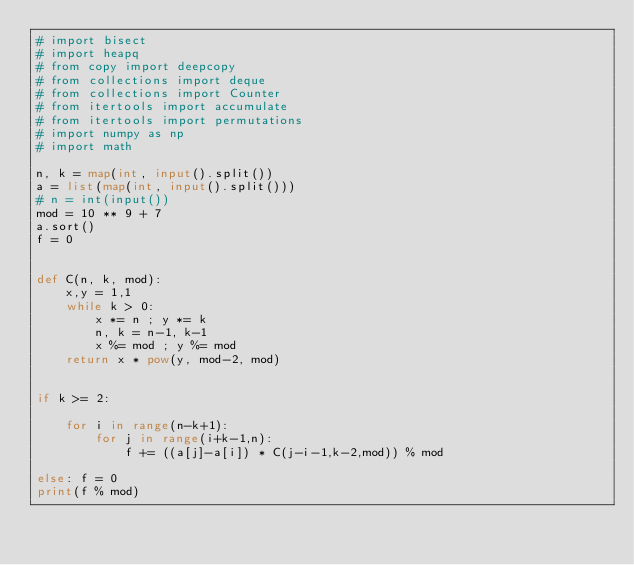<code> <loc_0><loc_0><loc_500><loc_500><_Python_># import bisect
# import heapq
# from copy import deepcopy
# from collections import deque
# from collections import Counter
# from itertools import accumulate
# from itertools import permutations
# import numpy as np
# import math

n, k = map(int, input().split())
a = list(map(int, input().split()))
# n = int(input())
mod = 10 ** 9 + 7
a.sort()
f = 0


def C(n, k, mod):
    x,y = 1,1
    while k > 0:
        x *= n ; y *= k
        n, k = n-1, k-1
        x %= mod ; y %= mod
    return x * pow(y, mod-2, mod)


if k >= 2:

    for i in range(n-k+1):
        for j in range(i+k-1,n):
            f += ((a[j]-a[i]) * C(j-i-1,k-2,mod)) % mod

else: f = 0
print(f % mod)
</code> 